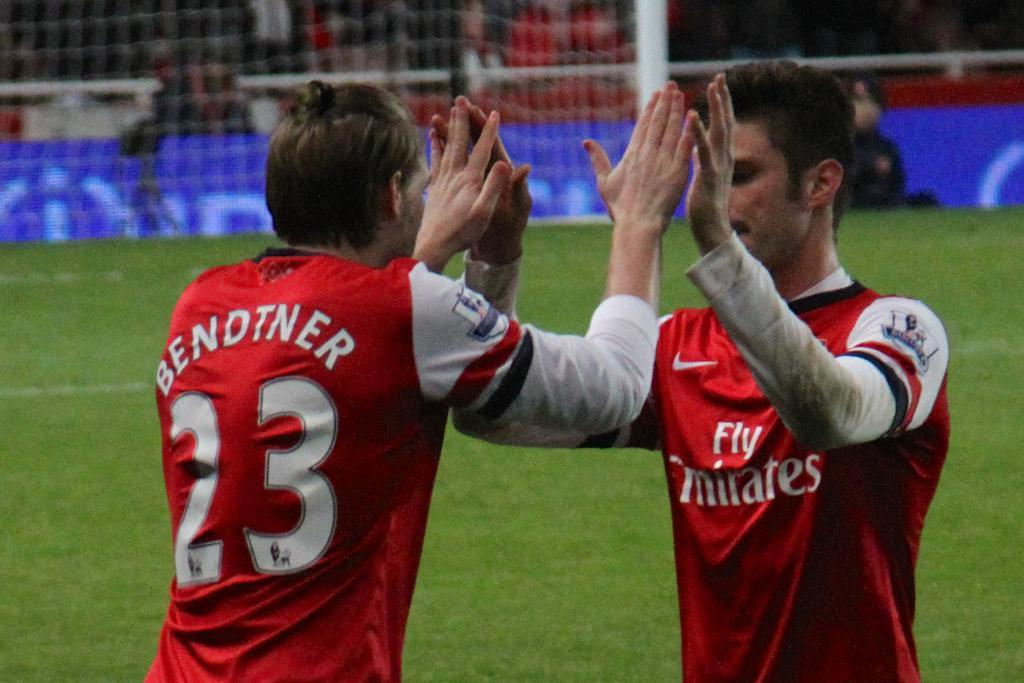Provide a one-sentence caption for the provided image. Two athletes high five each other in red and white jerseys which one says Bendtner 23 on the back. 